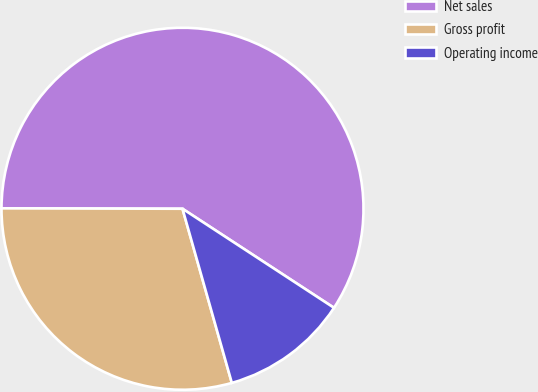<chart> <loc_0><loc_0><loc_500><loc_500><pie_chart><fcel>Net sales<fcel>Gross profit<fcel>Operating income<nl><fcel>59.18%<fcel>29.43%<fcel>11.39%<nl></chart> 